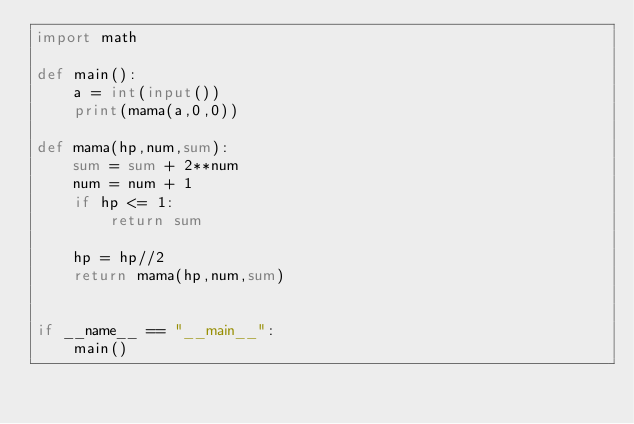<code> <loc_0><loc_0><loc_500><loc_500><_Python_>import math

def main():
    a = int(input())
    print(mama(a,0,0))

def mama(hp,num,sum):
    sum = sum + 2**num
    num = num + 1
    if hp <= 1:
        return sum

    hp = hp//2
    return mama(hp,num,sum)


if __name__ == "__main__":
    main()</code> 